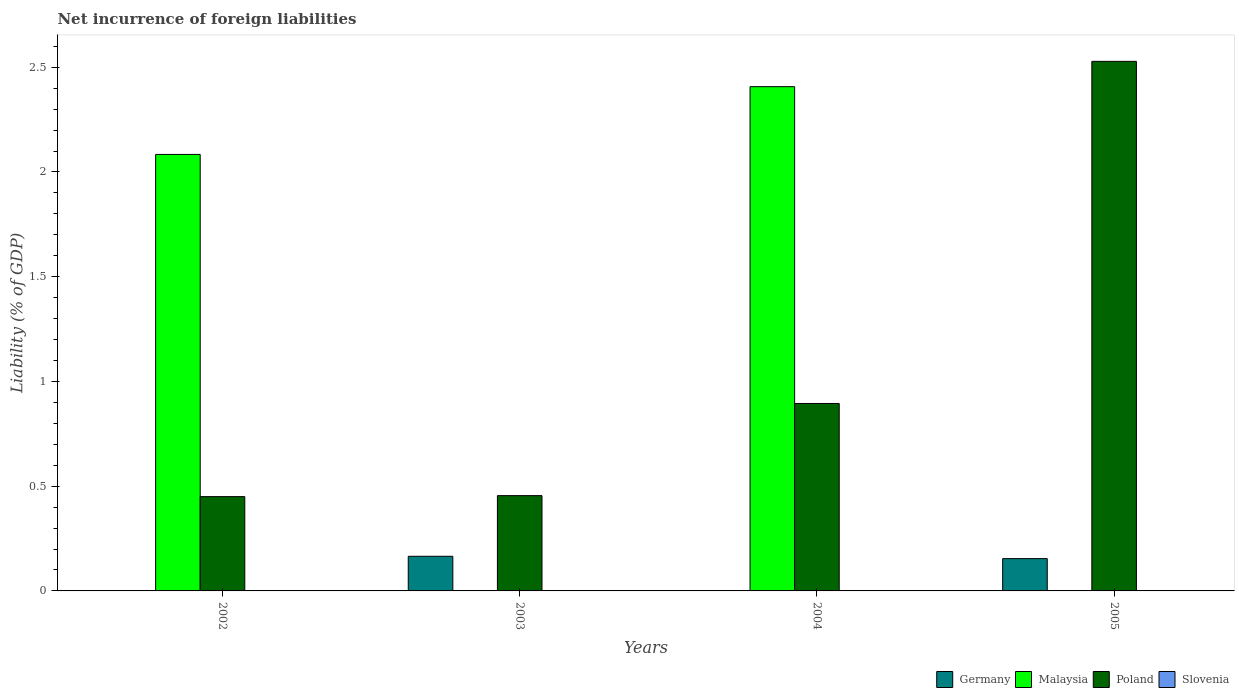How many groups of bars are there?
Ensure brevity in your answer.  4. Are the number of bars per tick equal to the number of legend labels?
Your answer should be compact. No. Are the number of bars on each tick of the X-axis equal?
Your answer should be compact. Yes. How many bars are there on the 2nd tick from the right?
Make the answer very short. 2. In how many cases, is the number of bars for a given year not equal to the number of legend labels?
Your response must be concise. 4. Across all years, what is the maximum net incurrence of foreign liabilities in Malaysia?
Ensure brevity in your answer.  2.41. Across all years, what is the minimum net incurrence of foreign liabilities in Malaysia?
Ensure brevity in your answer.  0. In which year was the net incurrence of foreign liabilities in Malaysia maximum?
Give a very brief answer. 2004. What is the total net incurrence of foreign liabilities in Germany in the graph?
Your response must be concise. 0.32. What is the difference between the net incurrence of foreign liabilities in Germany in 2003 and that in 2005?
Offer a very short reply. 0.01. What is the difference between the net incurrence of foreign liabilities in Germany in 2003 and the net incurrence of foreign liabilities in Poland in 2004?
Your answer should be very brief. -0.73. What is the average net incurrence of foreign liabilities in Malaysia per year?
Offer a very short reply. 1.12. In the year 2002, what is the difference between the net incurrence of foreign liabilities in Malaysia and net incurrence of foreign liabilities in Poland?
Offer a very short reply. 1.63. In how many years, is the net incurrence of foreign liabilities in Malaysia greater than 0.1 %?
Your response must be concise. 2. What is the ratio of the net incurrence of foreign liabilities in Malaysia in 2002 to that in 2004?
Keep it short and to the point. 0.87. Is the net incurrence of foreign liabilities in Malaysia in 2002 less than that in 2004?
Offer a terse response. Yes. What is the difference between the highest and the second highest net incurrence of foreign liabilities in Poland?
Your answer should be very brief. 1.63. What is the difference between the highest and the lowest net incurrence of foreign liabilities in Malaysia?
Keep it short and to the point. 2.41. Is the sum of the net incurrence of foreign liabilities in Poland in 2004 and 2005 greater than the maximum net incurrence of foreign liabilities in Germany across all years?
Your response must be concise. Yes. Is it the case that in every year, the sum of the net incurrence of foreign liabilities in Germany and net incurrence of foreign liabilities in Poland is greater than the net incurrence of foreign liabilities in Slovenia?
Provide a succinct answer. Yes. How many bars are there?
Provide a short and direct response. 8. How many years are there in the graph?
Your answer should be compact. 4. Are the values on the major ticks of Y-axis written in scientific E-notation?
Your answer should be compact. No. Where does the legend appear in the graph?
Make the answer very short. Bottom right. What is the title of the graph?
Your answer should be compact. Net incurrence of foreign liabilities. Does "Togo" appear as one of the legend labels in the graph?
Offer a very short reply. No. What is the label or title of the X-axis?
Offer a terse response. Years. What is the label or title of the Y-axis?
Make the answer very short. Liability (% of GDP). What is the Liability (% of GDP) in Germany in 2002?
Offer a very short reply. 0. What is the Liability (% of GDP) in Malaysia in 2002?
Your answer should be very brief. 2.08. What is the Liability (% of GDP) of Poland in 2002?
Offer a terse response. 0.45. What is the Liability (% of GDP) of Germany in 2003?
Your response must be concise. 0.17. What is the Liability (% of GDP) of Malaysia in 2003?
Your answer should be very brief. 0. What is the Liability (% of GDP) of Poland in 2003?
Offer a very short reply. 0.45. What is the Liability (% of GDP) of Slovenia in 2003?
Offer a terse response. 0. What is the Liability (% of GDP) of Malaysia in 2004?
Provide a short and direct response. 2.41. What is the Liability (% of GDP) in Poland in 2004?
Offer a terse response. 0.89. What is the Liability (% of GDP) of Slovenia in 2004?
Offer a terse response. 0. What is the Liability (% of GDP) of Germany in 2005?
Give a very brief answer. 0.15. What is the Liability (% of GDP) in Malaysia in 2005?
Provide a short and direct response. 0. What is the Liability (% of GDP) in Poland in 2005?
Offer a very short reply. 2.53. Across all years, what is the maximum Liability (% of GDP) in Germany?
Your response must be concise. 0.17. Across all years, what is the maximum Liability (% of GDP) of Malaysia?
Your response must be concise. 2.41. Across all years, what is the maximum Liability (% of GDP) in Poland?
Make the answer very short. 2.53. Across all years, what is the minimum Liability (% of GDP) in Malaysia?
Make the answer very short. 0. Across all years, what is the minimum Liability (% of GDP) of Poland?
Give a very brief answer. 0.45. What is the total Liability (% of GDP) in Germany in the graph?
Ensure brevity in your answer.  0.32. What is the total Liability (% of GDP) of Malaysia in the graph?
Offer a very short reply. 4.49. What is the total Liability (% of GDP) of Poland in the graph?
Make the answer very short. 4.33. What is the difference between the Liability (% of GDP) of Poland in 2002 and that in 2003?
Your response must be concise. -0. What is the difference between the Liability (% of GDP) of Malaysia in 2002 and that in 2004?
Keep it short and to the point. -0.32. What is the difference between the Liability (% of GDP) in Poland in 2002 and that in 2004?
Make the answer very short. -0.44. What is the difference between the Liability (% of GDP) of Poland in 2002 and that in 2005?
Provide a succinct answer. -2.08. What is the difference between the Liability (% of GDP) of Poland in 2003 and that in 2004?
Ensure brevity in your answer.  -0.44. What is the difference between the Liability (% of GDP) of Germany in 2003 and that in 2005?
Make the answer very short. 0.01. What is the difference between the Liability (% of GDP) of Poland in 2003 and that in 2005?
Keep it short and to the point. -2.07. What is the difference between the Liability (% of GDP) in Poland in 2004 and that in 2005?
Ensure brevity in your answer.  -1.63. What is the difference between the Liability (% of GDP) of Malaysia in 2002 and the Liability (% of GDP) of Poland in 2003?
Your answer should be compact. 1.63. What is the difference between the Liability (% of GDP) in Malaysia in 2002 and the Liability (% of GDP) in Poland in 2004?
Provide a succinct answer. 1.19. What is the difference between the Liability (% of GDP) in Malaysia in 2002 and the Liability (% of GDP) in Poland in 2005?
Make the answer very short. -0.44. What is the difference between the Liability (% of GDP) of Germany in 2003 and the Liability (% of GDP) of Malaysia in 2004?
Offer a terse response. -2.24. What is the difference between the Liability (% of GDP) of Germany in 2003 and the Liability (% of GDP) of Poland in 2004?
Offer a terse response. -0.73. What is the difference between the Liability (% of GDP) of Germany in 2003 and the Liability (% of GDP) of Poland in 2005?
Offer a terse response. -2.36. What is the difference between the Liability (% of GDP) of Malaysia in 2004 and the Liability (% of GDP) of Poland in 2005?
Provide a succinct answer. -0.12. What is the average Liability (% of GDP) in Germany per year?
Provide a succinct answer. 0.08. What is the average Liability (% of GDP) of Malaysia per year?
Provide a succinct answer. 1.12. What is the average Liability (% of GDP) in Poland per year?
Your answer should be compact. 1.08. In the year 2002, what is the difference between the Liability (% of GDP) of Malaysia and Liability (% of GDP) of Poland?
Provide a short and direct response. 1.63. In the year 2003, what is the difference between the Liability (% of GDP) in Germany and Liability (% of GDP) in Poland?
Provide a succinct answer. -0.29. In the year 2004, what is the difference between the Liability (% of GDP) in Malaysia and Liability (% of GDP) in Poland?
Ensure brevity in your answer.  1.51. In the year 2005, what is the difference between the Liability (% of GDP) in Germany and Liability (% of GDP) in Poland?
Provide a short and direct response. -2.37. What is the ratio of the Liability (% of GDP) in Poland in 2002 to that in 2003?
Your response must be concise. 0.99. What is the ratio of the Liability (% of GDP) in Malaysia in 2002 to that in 2004?
Provide a succinct answer. 0.87. What is the ratio of the Liability (% of GDP) in Poland in 2002 to that in 2004?
Offer a terse response. 0.5. What is the ratio of the Liability (% of GDP) of Poland in 2002 to that in 2005?
Your answer should be very brief. 0.18. What is the ratio of the Liability (% of GDP) of Poland in 2003 to that in 2004?
Keep it short and to the point. 0.51. What is the ratio of the Liability (% of GDP) of Germany in 2003 to that in 2005?
Offer a very short reply. 1.07. What is the ratio of the Liability (% of GDP) of Poland in 2003 to that in 2005?
Provide a succinct answer. 0.18. What is the ratio of the Liability (% of GDP) in Poland in 2004 to that in 2005?
Provide a succinct answer. 0.35. What is the difference between the highest and the second highest Liability (% of GDP) in Poland?
Your answer should be very brief. 1.63. What is the difference between the highest and the lowest Liability (% of GDP) of Germany?
Ensure brevity in your answer.  0.17. What is the difference between the highest and the lowest Liability (% of GDP) of Malaysia?
Your response must be concise. 2.41. What is the difference between the highest and the lowest Liability (% of GDP) of Poland?
Provide a succinct answer. 2.08. 